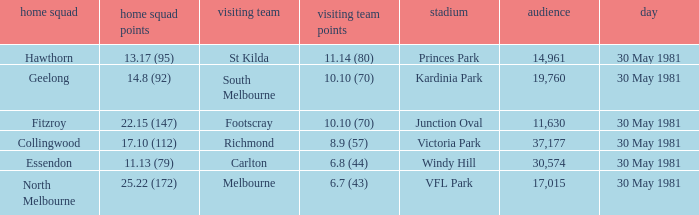What did carlton score while away? 6.8 (44). 